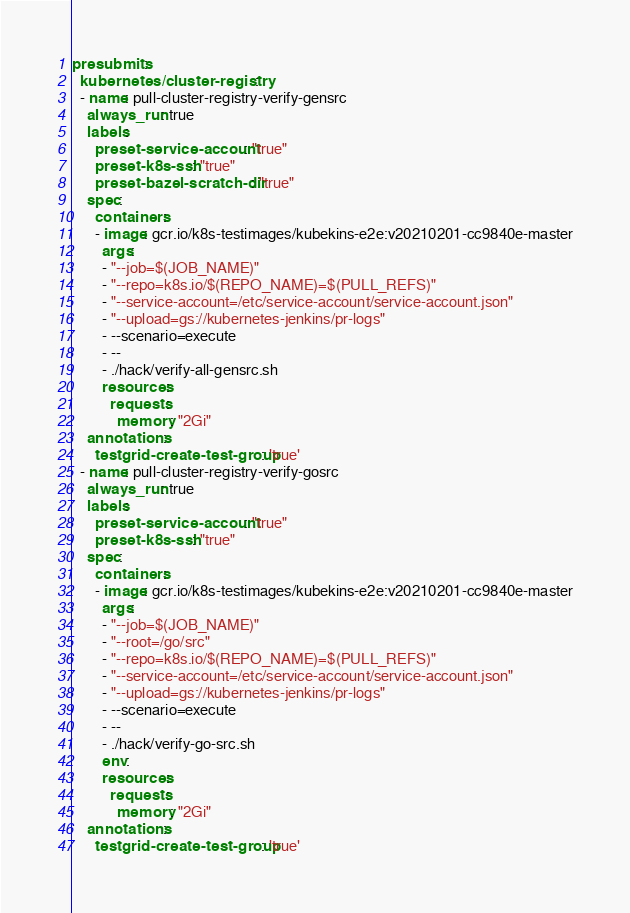Convert code to text. <code><loc_0><loc_0><loc_500><loc_500><_YAML_>presubmits:
  kubernetes/cluster-registry:
  - name: pull-cluster-registry-verify-gensrc
    always_run: true
    labels:
      preset-service-account: "true"
      preset-k8s-ssh: "true"
      preset-bazel-scratch-dir: "true"
    spec:
      containers:
      - image: gcr.io/k8s-testimages/kubekins-e2e:v20210201-cc9840e-master
        args:
        - "--job=$(JOB_NAME)"
        - "--repo=k8s.io/$(REPO_NAME)=$(PULL_REFS)"
        - "--service-account=/etc/service-account/service-account.json"
        - "--upload=gs://kubernetes-jenkins/pr-logs"
        - --scenario=execute
        - --
        - ./hack/verify-all-gensrc.sh
        resources:
          requests:
            memory: "2Gi"
    annotations:
      testgrid-create-test-group: 'true'
  - name: pull-cluster-registry-verify-gosrc
    always_run: true
    labels:
      preset-service-account: "true"
      preset-k8s-ssh: "true"
    spec:
      containers:
      - image: gcr.io/k8s-testimages/kubekins-e2e:v20210201-cc9840e-master
        args:
        - "--job=$(JOB_NAME)"
        - "--root=/go/src"
        - "--repo=k8s.io/$(REPO_NAME)=$(PULL_REFS)"
        - "--service-account=/etc/service-account/service-account.json"
        - "--upload=gs://kubernetes-jenkins/pr-logs"
        - --scenario=execute
        - --
        - ./hack/verify-go-src.sh
        env:
        resources:
          requests:
            memory: "2Gi"
    annotations:
      testgrid-create-test-group: 'true'
</code> 